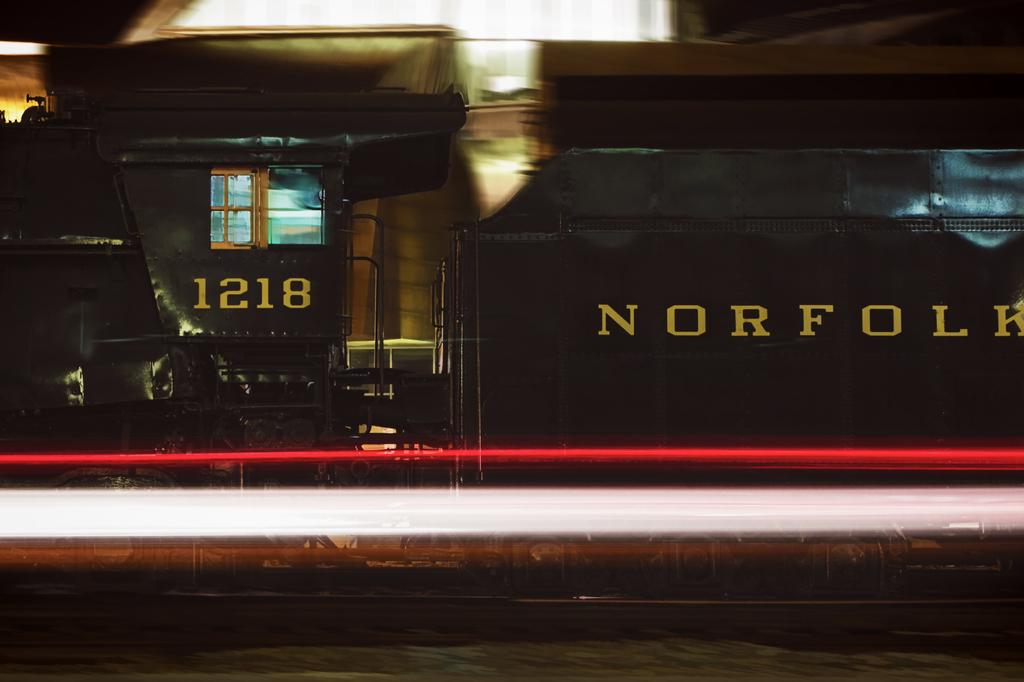What is the main subject of the image? There is a train in the image. What colors are used to paint the train? The train is black and yellow in color. Can you describe any specific features of the train? There is a window on the train. How would you describe the background of the image? The background is blurry, and there are lights and other objects visible. What type of bee can be seen flying near the train in the image? There is no bee present in the image; it only features a train and a blurry background. What emotion does the train feel as it moves through the scene? Trains do not have emotions, so it is not possible to determine how the train feels in the image. 